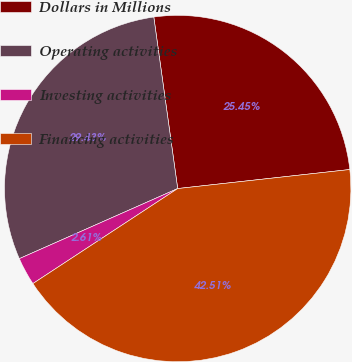Convert chart. <chart><loc_0><loc_0><loc_500><loc_500><pie_chart><fcel>Dollars in Millions<fcel>Operating activities<fcel>Investing activities<fcel>Financing activities<nl><fcel>25.45%<fcel>29.43%<fcel>2.61%<fcel>42.51%<nl></chart> 